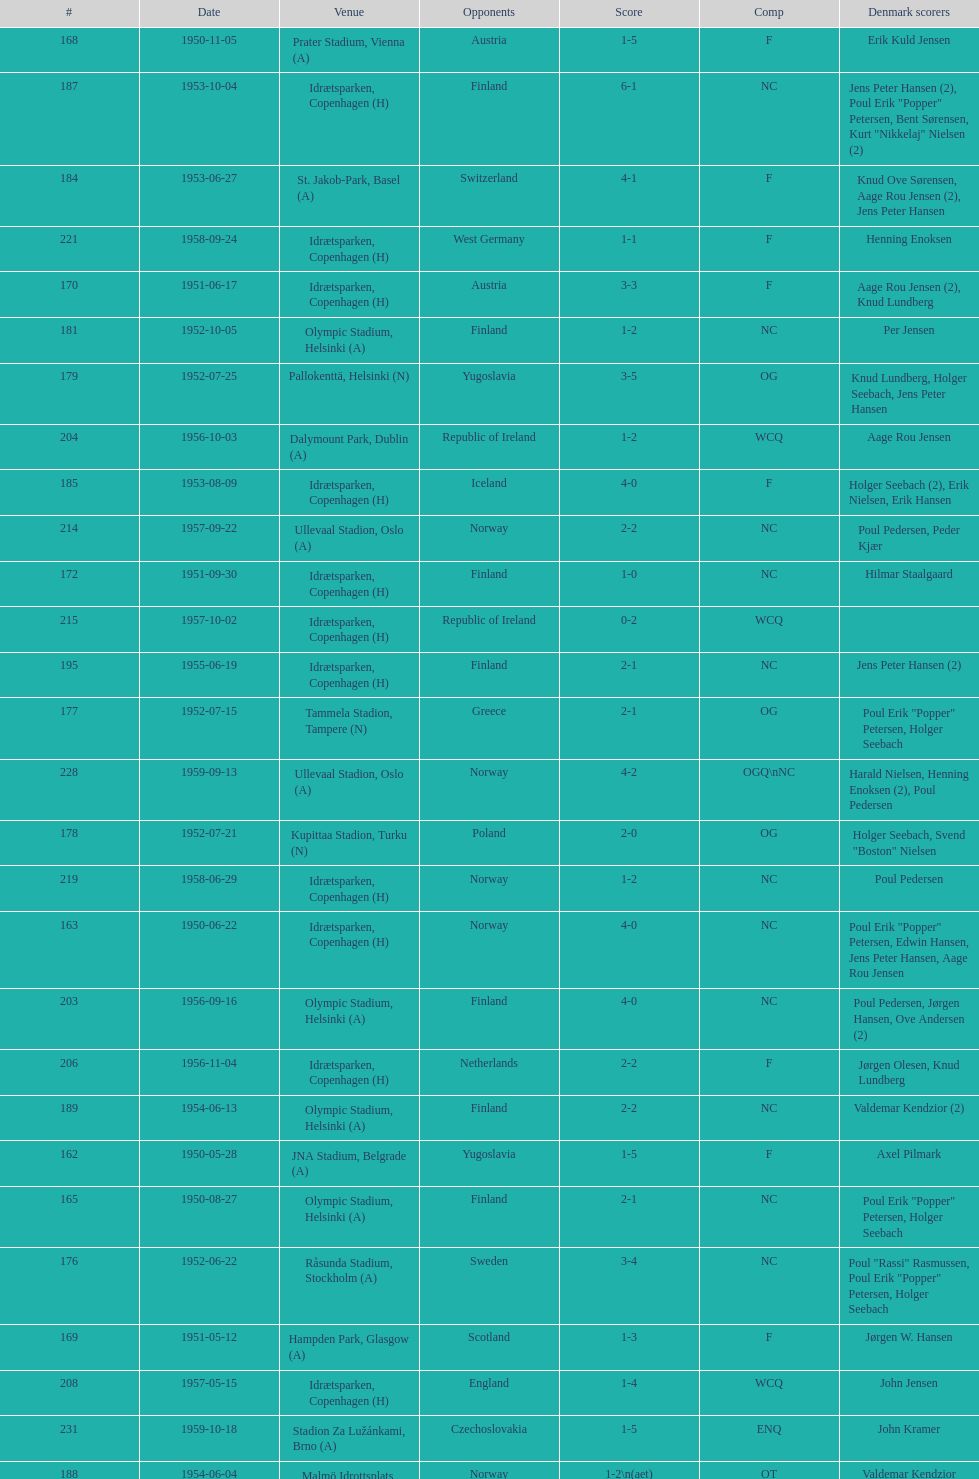What is the name of the venue listed before olympic stadium on 1950-08-27? Aarhus Stadion, Aarhus. 